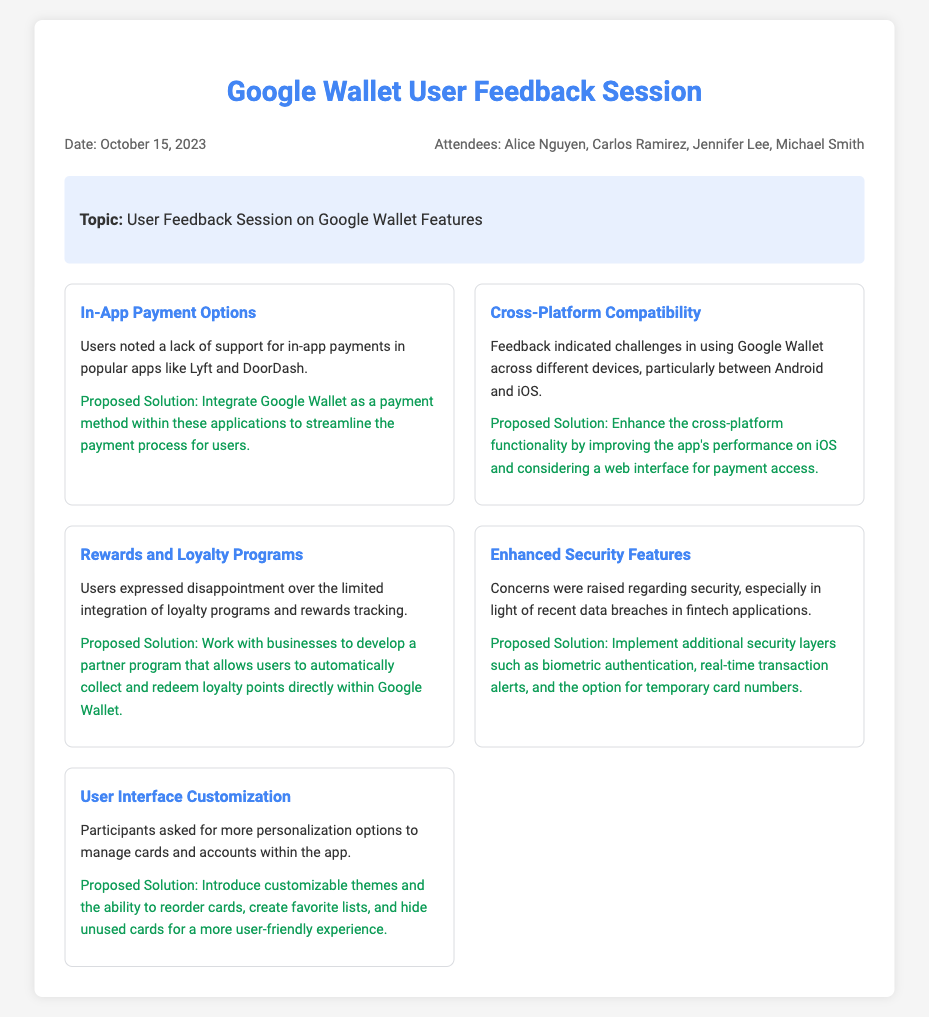What is the date of the user feedback session? The date of the user feedback session is written at the top of the document.
Answer: October 15, 2023 Who is one of the attendees at the session? The list of attendees is provided in the document, including names mentioned.
Answer: Alice Nguyen What is the feature related to in-app payment options? The document specifies the feature about in-app payment options in the insights section.
Answer: In-App Payment Options What was a concern raised regarding security? The feedback mentions security concerns specifically tied to recent data breaches.
Answer: Security What is the proposed solution for enhancing user interface customization? The document describes proposed solutions for each feature, including user interface options.
Answer: Introduce customizable themes How many attendees are listed in the document? The attendees are listed at the top, providing a count of individuals present.
Answer: Four What issue did users face with cross-platform compatibility? The feedback outlines challenges users faced in the context of the specific compatibility.
Answer: Challenges in using Google Wallet across different devices What type of programs users expressed disappointment over? The insights mention specific areas where users felt there was a lack of integration.
Answer: Loyalty programs 